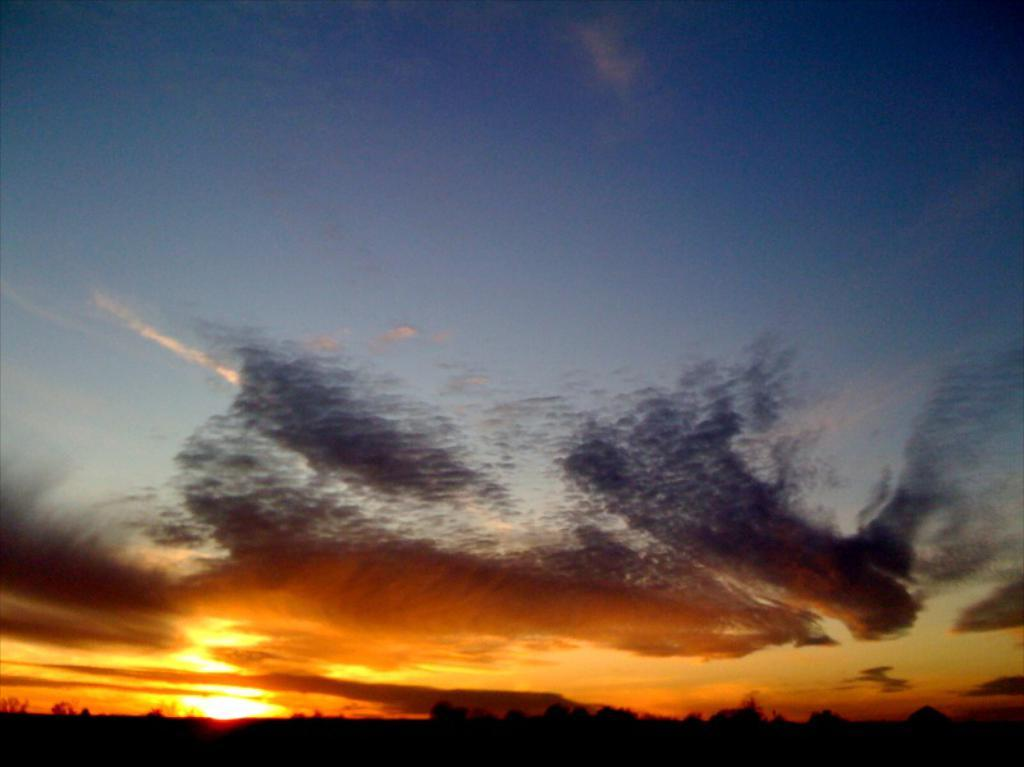What can be seen at the top of the image? The sky is visible in the image. How would you describe the appearance of the sky? The sky is colorful. What celestial body is present in the sky? There is a sun in the sky. What type of vegetation is at the bottom of the image? Trees are present at the bottom of the image. How would you describe the lighting at the bottom of the image? The bottom of the image is dark. Can you see your aunt holding a fork in the image? There is no person, let alone an aunt, holding a fork in the image. 